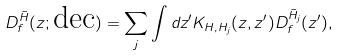Convert formula to latex. <formula><loc_0><loc_0><loc_500><loc_500>D _ { f } ^ { \bar { H } } ( z ; \text {dec} ) = \sum _ { j } \int d z ^ { \prime } K _ { H , H _ { j } } ( z , z ^ { \prime } ) D _ { f } ^ { \bar { H } _ { j } } ( z ^ { \prime } ) ,</formula> 